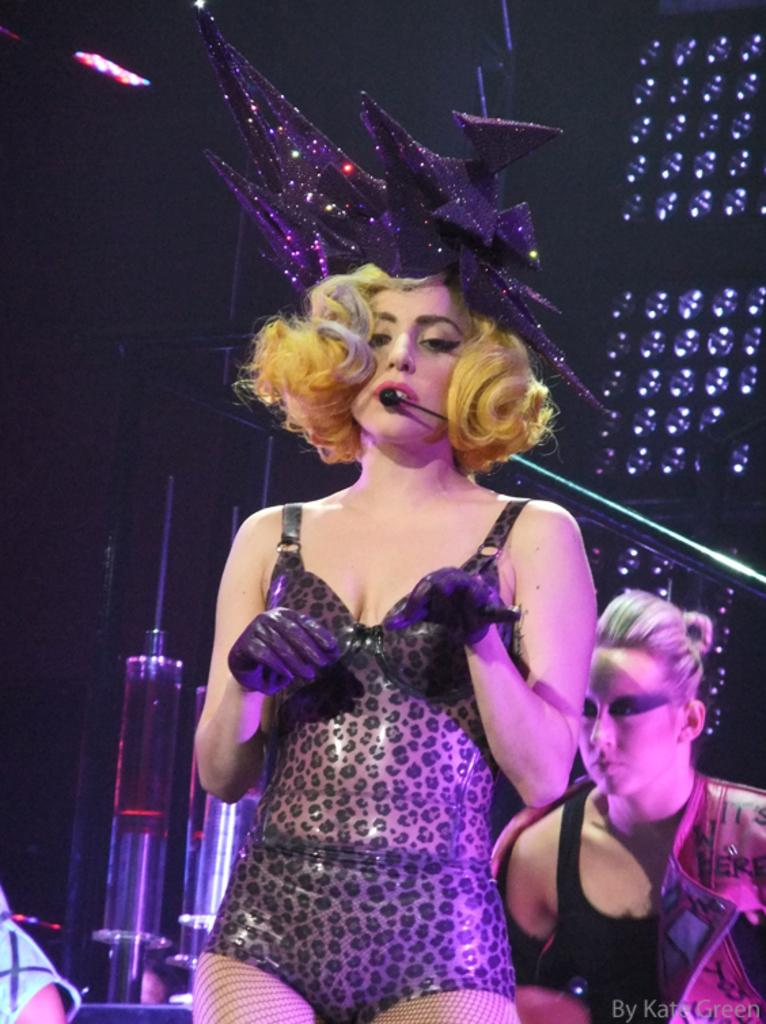What is the person in the image doing? There is a person standing in the image. What is the person wearing? The person is wearing a black dress. What object is present in the image that is commonly used for amplifying sound? There is a microphone in the image. What can be seen in the background of the image? There are lights visible in the background of the image. What type of pets can be seen in the image? There are no pets visible in the image. What is the texture of the microphone in the image? The texture of the microphone cannot be determined from the image alone. 